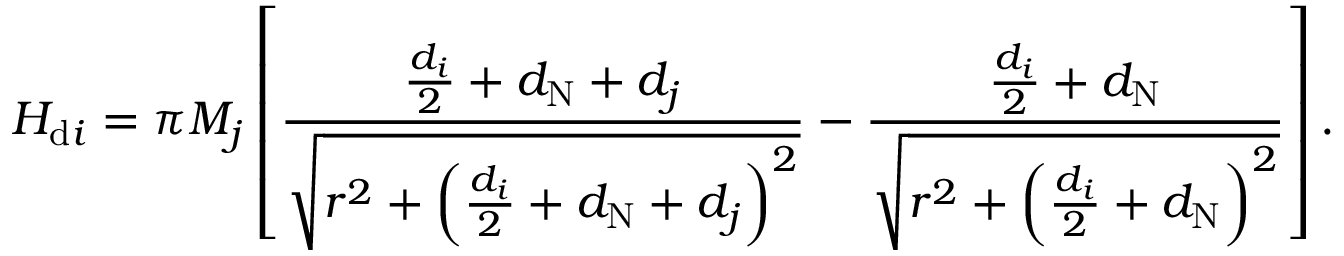<formula> <loc_0><loc_0><loc_500><loc_500>H _ { d i } = \pi M _ { j } \left [ \frac { \frac { d _ { i } } { 2 } + d _ { N } + d _ { j } } { \sqrt { r ^ { 2 } + \left ( \frac { d _ { i } } { 2 } + d _ { N } + d _ { j } \right ) ^ { 2 } } } - \frac { \frac { d _ { i } } { 2 } + d _ { N } } { \sqrt { r ^ { 2 } + \left ( \frac { d _ { i } } { 2 } + d _ { N } \right ) ^ { 2 } } } \right ] .</formula> 